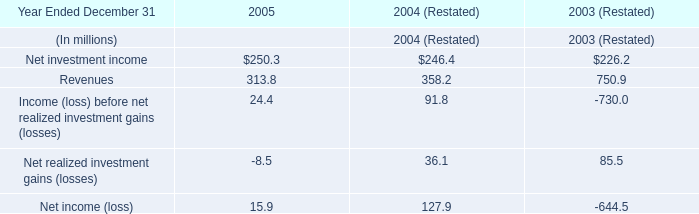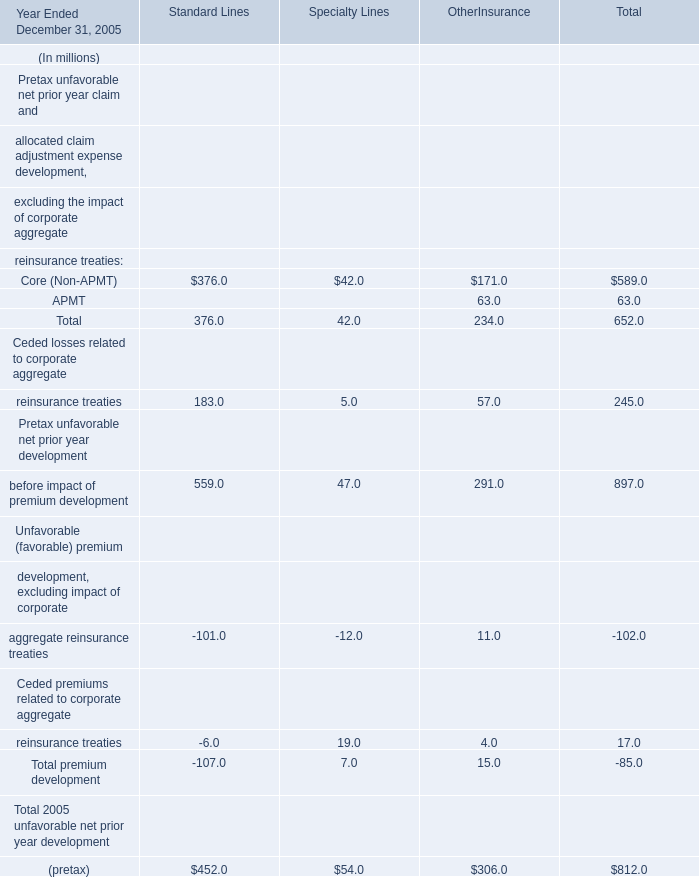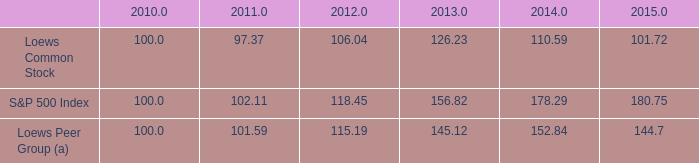what was the overall growth of the s&p 500 index from 2010 to 2015 
Computations: ((180.75 - 100.0) / 100)
Answer: 0.8075. 